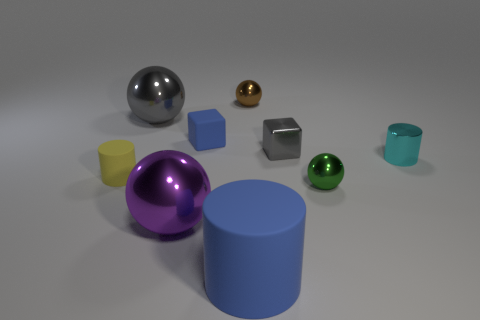There is a green object that is made of the same material as the small gray block; what is its shape?
Ensure brevity in your answer.  Sphere. Are there fewer large purple metal objects that are behind the tiny green metallic thing than small gray shiny cubes?
Make the answer very short. Yes. What is the color of the metal thing in front of the green shiny sphere?
Your answer should be compact. Purple. There is a big object that is the same color as the small metallic cube; what is its material?
Your answer should be very brief. Metal. Is there a tiny brown metal object of the same shape as the big gray thing?
Provide a short and direct response. Yes. How many brown metal objects are the same shape as the yellow thing?
Your answer should be compact. 0. Do the matte cube and the big cylinder have the same color?
Keep it short and to the point. Yes. Is the number of cyan objects less than the number of tiny things?
Ensure brevity in your answer.  Yes. What is the small block on the left side of the small brown metallic sphere made of?
Offer a terse response. Rubber. There is a yellow cylinder that is the same size as the green sphere; what material is it?
Provide a short and direct response. Rubber. 